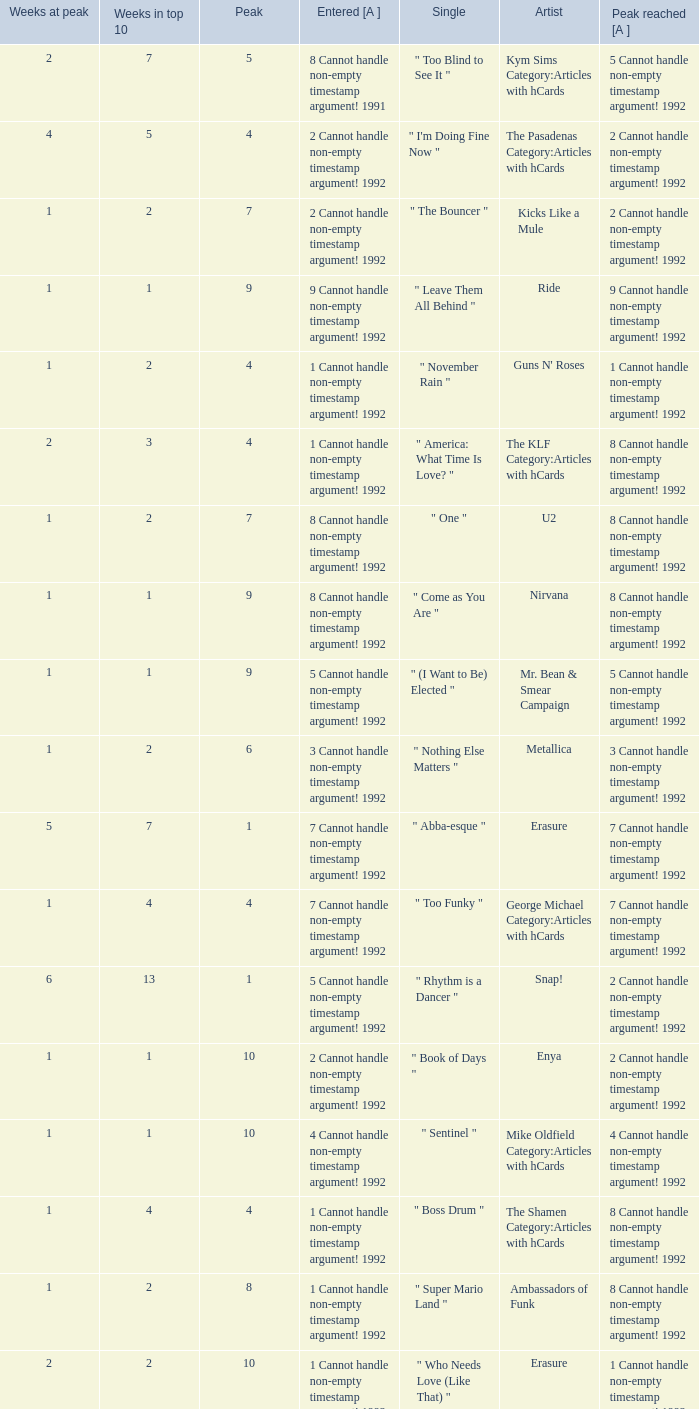If the peak is 9, how many weeks was it in the top 10? 1.0. 